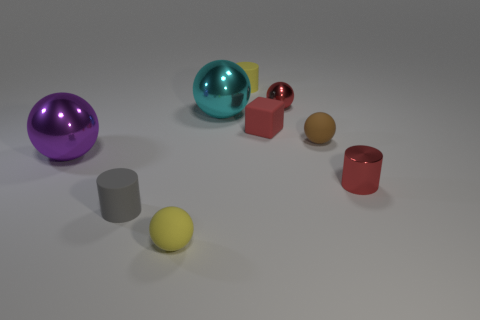Which objects appear to be reflective? The turquoise and red objects exhibit a reflective surface, which can be inferred from the visible highlights and environment reflections on them. 